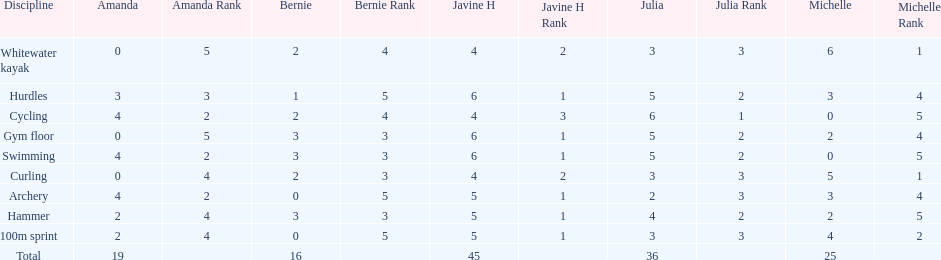Who is the faster runner? Javine H. 